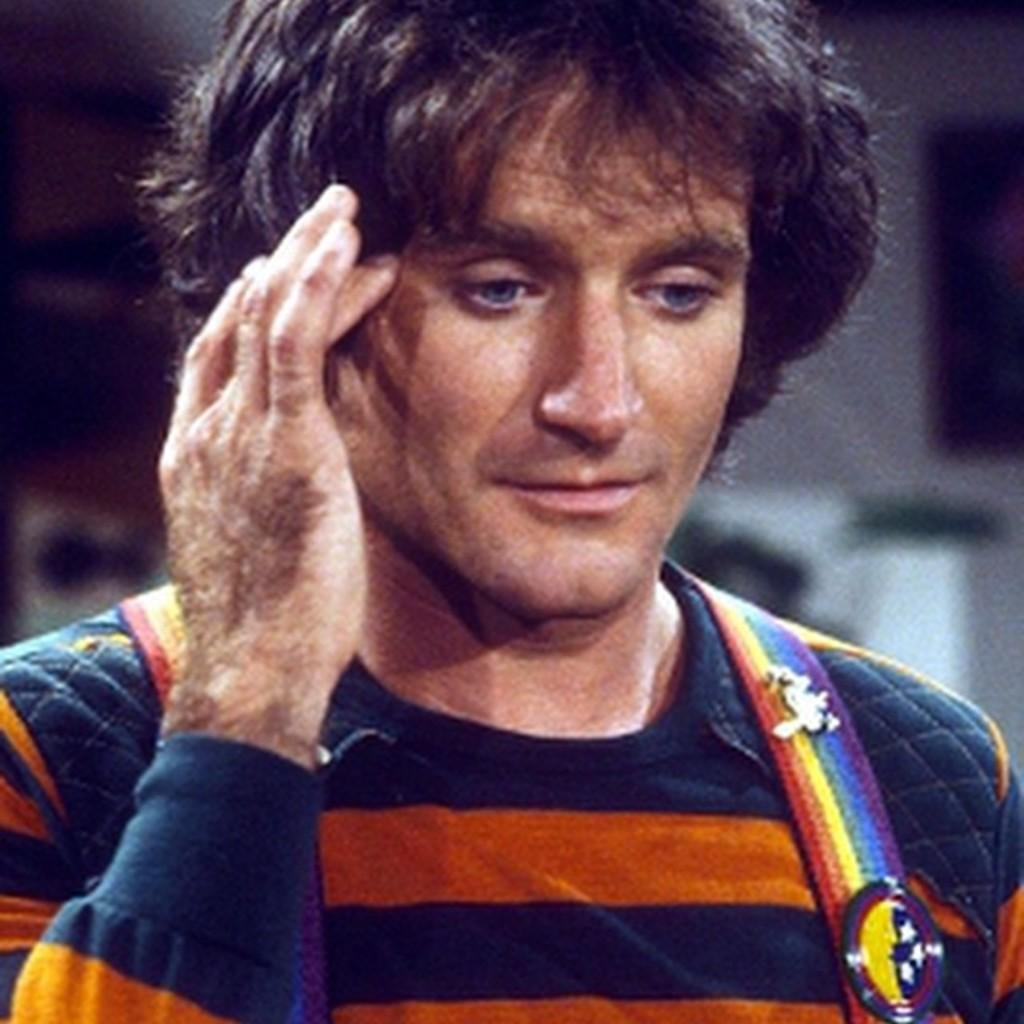Who is present in the image? There is a man in the image. What is the man wearing? The man is wearing an orange and blue T-shirt. Can you describe the background of the image? The background of the image is blurred. How many dimes can be seen on the man's T-shirt in the image? There are no dimes visible on the man's T-shirt in the image. What unit of measurement is used to describe the size of the man's T-shirt in the image? The size of the man's T-shirt is not mentioned in the image, so we cannot determine the unit of measurement used. 